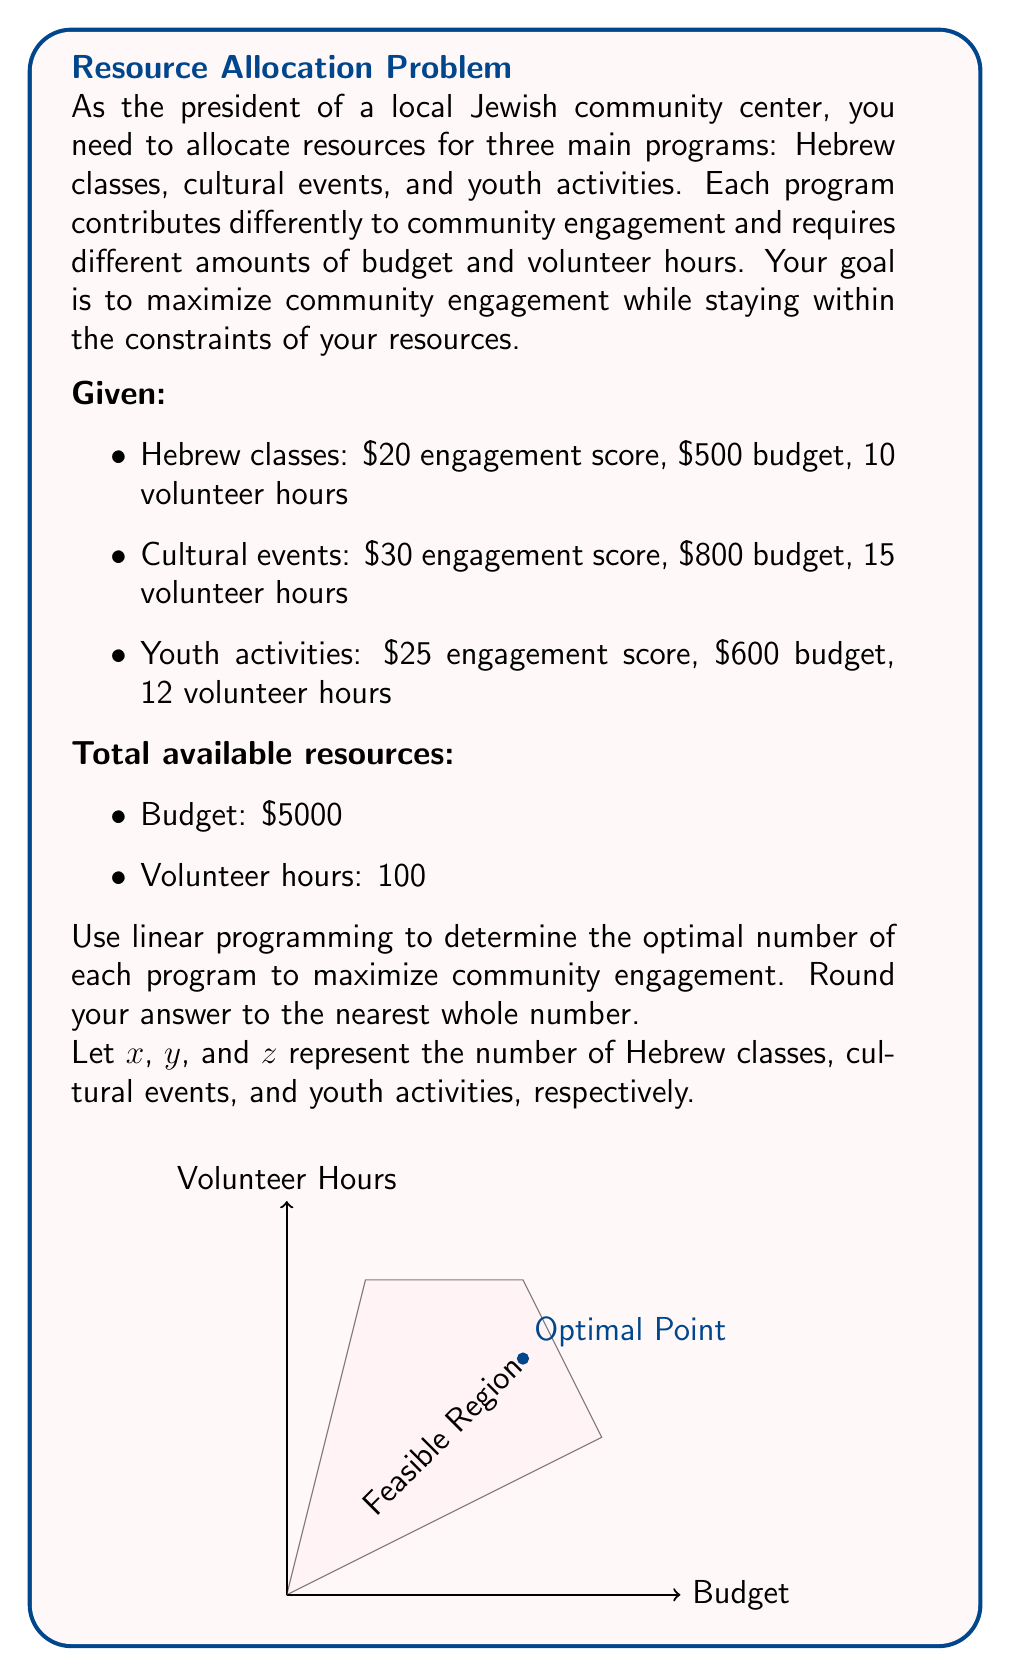Can you solve this math problem? Let's approach this step-by-step using linear programming:

1) Define the objective function:
   Maximize $Z = 20x + 30y + 25z$

2) Set up the constraints:
   Budget: $500x + 800y + 600z \leq 5000$
   Volunteer hours: $10x + 15y + 12z \leq 100$
   Non-negativity: $x, y, z \geq 0$

3) Solve using the simplex method or a linear programming solver. Here's the process:

   a) Convert inequalities to equations by adding slack variables:
      $500x + 800y + 600z + s_1 = 5000$
      $10x + 15y + 12z + s_2 = 100$

   b) Set up the initial simplex tableau:
      $$\begin{array}{c|cccccc|c}
         & x & y & z & s_1 & s_2 & Z & RHS \\
      \hline
      s_1 & 500 & 800 & 600 & 1 & 0 & 0 & 5000 \\
      s_2 & 10 & 15 & 12 & 0 & 1 & 0 & 100 \\
      Z & -20 & -30 & -25 & 0 & 0 & 1 & 0
      \end{array}$$

   c) After several iterations, we reach the optimal solution:
      $$\begin{array}{c|cccccc|c}
         & x & y & z & s_1 & s_2 & Z & RHS \\
      \hline
      y & 0 & 1 & 0 & 1/400 & -1/120 & 0 & 5 \\
      z & 0 & 0 & 1 & -1/200 & 1/30 & 0 & 2.5 \\
      Z & 0 & 0 & 0 & 1/8 & 5/4 & 1 & 212.5
      \end{array}$$

4) Interpret the results:
   $y = 5$ (cultural events)
   $z = 2.5$ (youth activities)
   $x = 0$ (Hebrew classes)

5) Round to the nearest whole number:
   5 cultural events
   3 youth activities
   0 Hebrew classes

This solution maximizes community engagement at 212.5 points.
Answer: 5 cultural events, 3 youth activities, 0 Hebrew classes 